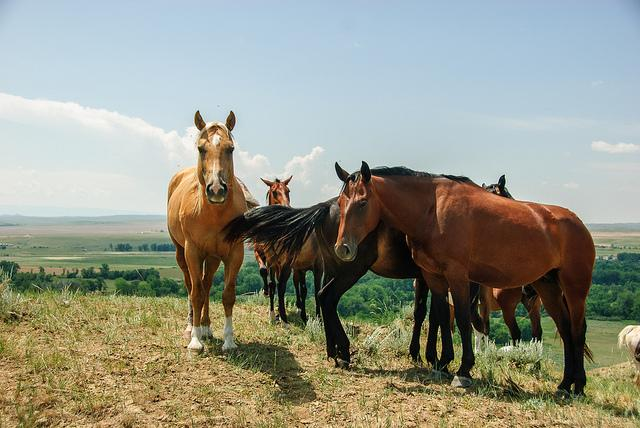What is above the horses? sky 